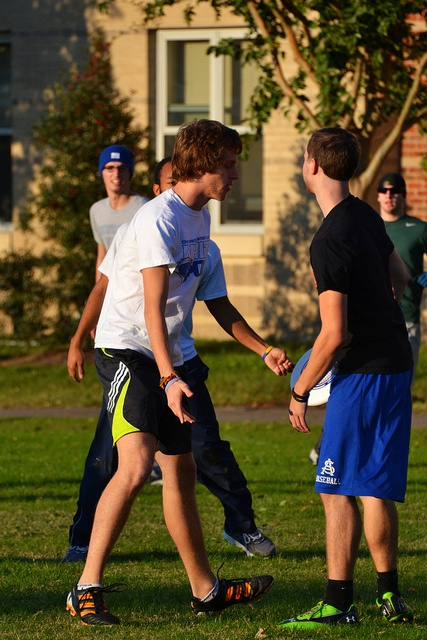Describe the objects in this image and their specific colors. I can see people in black, white, salmon, and maroon tones, people in black, navy, salmon, and darkblue tones, people in black, brown, navy, and maroon tones, people in black, darkgreen, teal, and maroon tones, and people in black, darkgray, tan, and salmon tones in this image. 